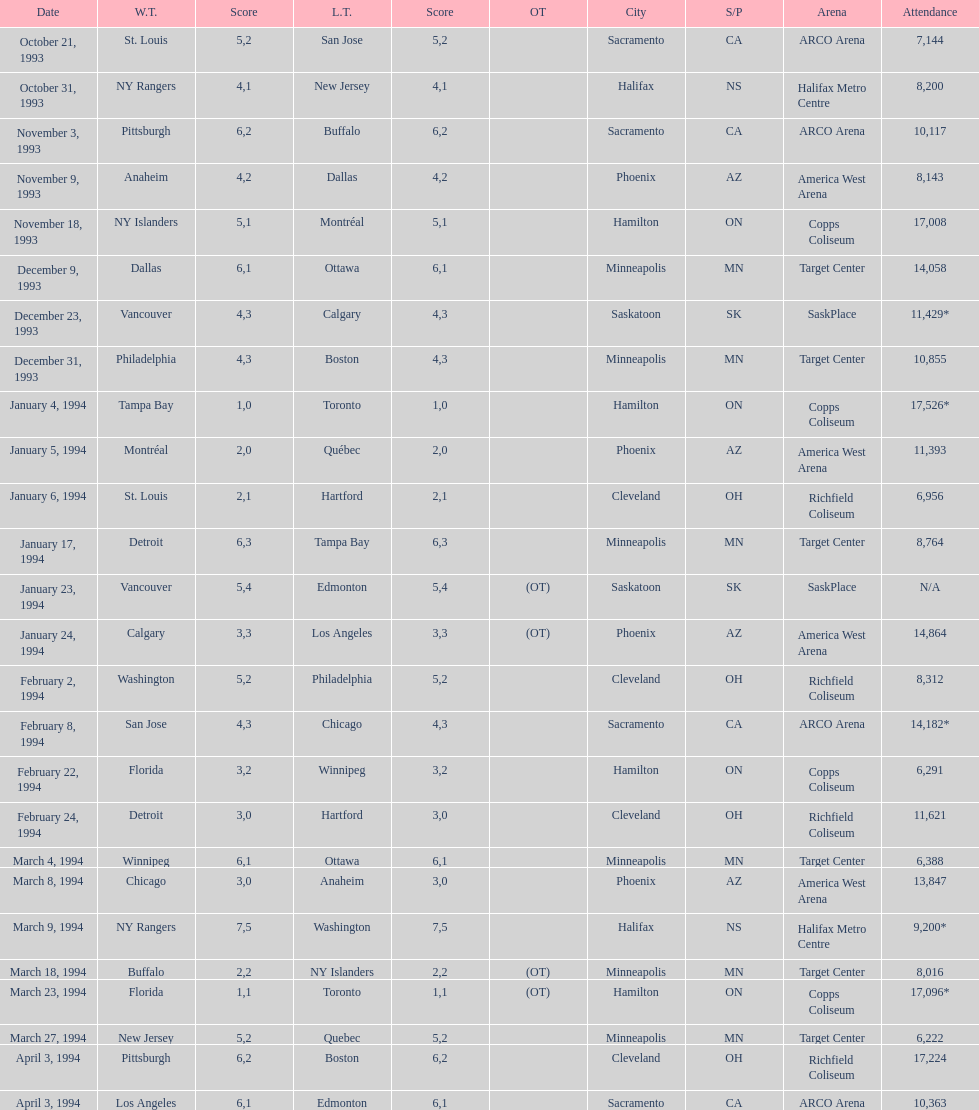How many additional individuals attended the november 18, 1993 games compared to the november 9th game? 8865. 